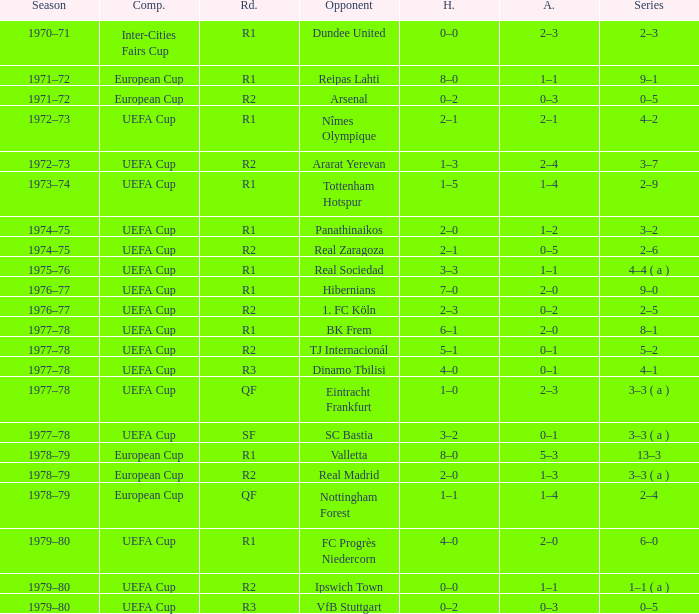Which Home has a Competition of european cup, and a Round of qf? 1–1. 